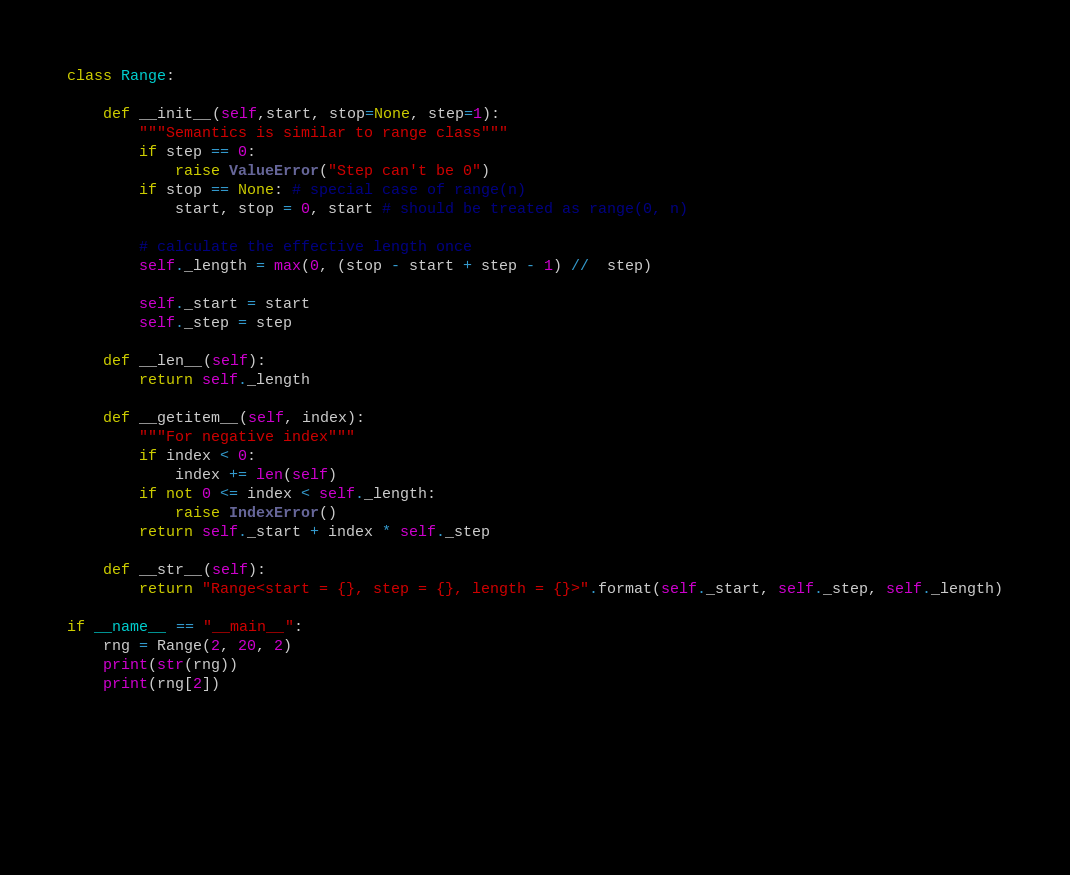<code> <loc_0><loc_0><loc_500><loc_500><_Python_>class Range:
    
    def __init__(self,start, stop=None, step=1):
        """Semantics is similar to range class"""
        if step == 0:
            raise ValueError("Step can't be 0")
        if stop == None: # special case of range(n)
            start, stop = 0, start # should be treated as range(0, n)
    
        # calculate the effective length once
        self._length = max(0, (stop - start + step - 1) //  step)

        self._start = start
        self._step = step

    def __len__(self):
        return self._length
        
    def __getitem__(self, index):
        """For negative index"""
        if index < 0:
            index += len(self)
        if not 0 <= index < self._length:
            raise IndexError()
        return self._start + index * self._step
        
    def __str__(self):
        return "Range<start = {}, step = {}, length = {}>".format(self._start, self._step, self._length)

if __name__ == "__main__":
    rng = Range(2, 20, 2)
    print(str(rng))
    print(rng[2])

        



    
</code> 